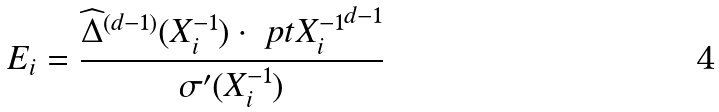Convert formula to latex. <formula><loc_0><loc_0><loc_500><loc_500>E _ { i } = \frac { \widehat { \Delta } ^ { ( d - 1 ) } ( X _ { i } ^ { - 1 } ) \cdot \ p t { X _ { i } ^ { - 1 } } ^ { d - 1 } } { \sigma ^ { \prime } ( X _ { i } ^ { - 1 } ) }</formula> 